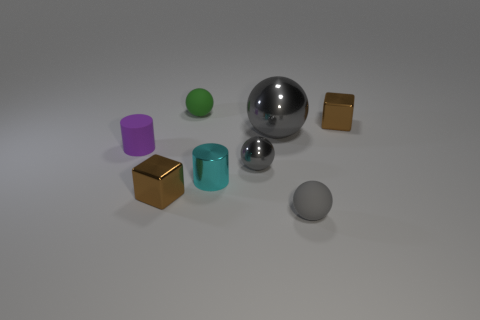Subtract all gray balls. How many were subtracted if there are1gray balls left? 2 Subtract all blue cubes. How many gray balls are left? 3 Subtract 1 balls. How many balls are left? 3 Add 1 red shiny blocks. How many objects exist? 9 Subtract all cylinders. How many objects are left? 6 Add 8 small metallic cubes. How many small metallic cubes exist? 10 Subtract 1 purple cylinders. How many objects are left? 7 Subtract all green cylinders. Subtract all large gray metal things. How many objects are left? 7 Add 2 large shiny things. How many large shiny things are left? 3 